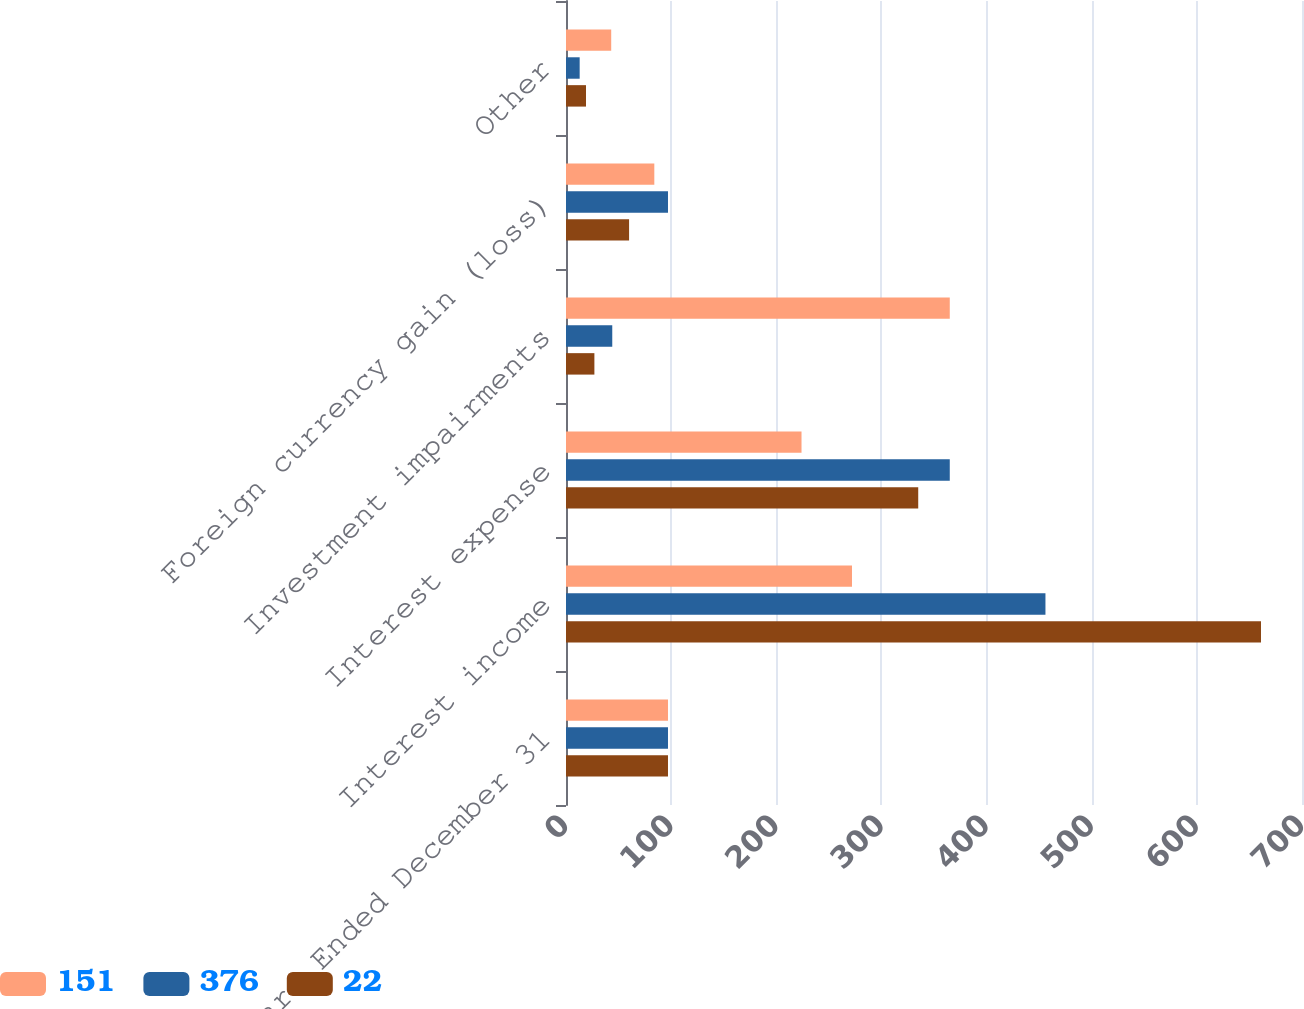<chart> <loc_0><loc_0><loc_500><loc_500><stacked_bar_chart><ecel><fcel>Years Ended December 31<fcel>Interest income<fcel>Interest expense<fcel>Investment impairments<fcel>Foreign currency gain (loss)<fcel>Other<nl><fcel>151<fcel>97<fcel>272<fcel>224<fcel>365<fcel>84<fcel>43<nl><fcel>376<fcel>97<fcel>456<fcel>365<fcel>44<fcel>97<fcel>13<nl><fcel>22<fcel>97<fcel>661<fcel>335<fcel>27<fcel>60<fcel>19<nl></chart> 